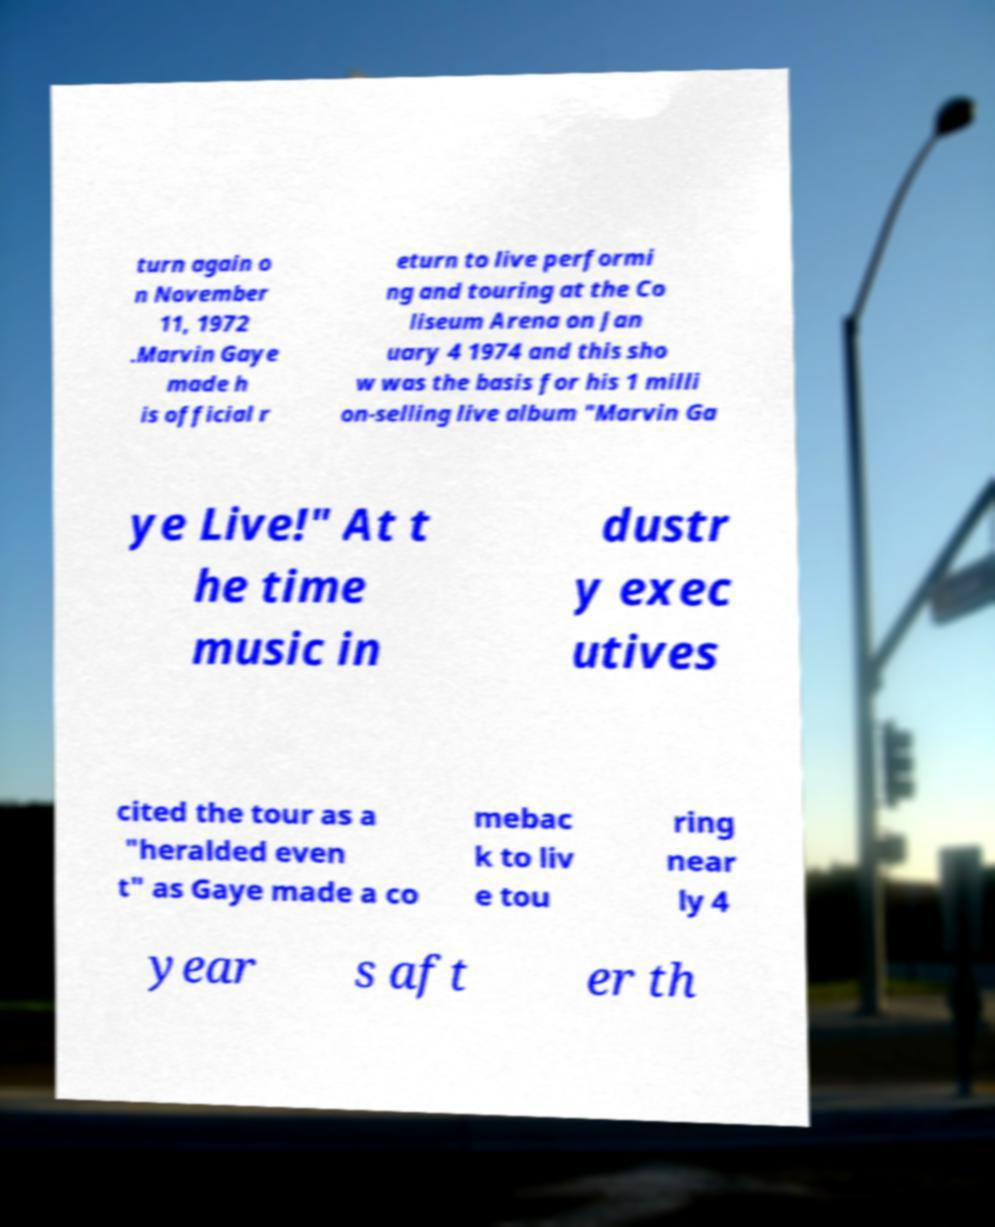Can you accurately transcribe the text from the provided image for me? turn again o n November 11, 1972 .Marvin Gaye made h is official r eturn to live performi ng and touring at the Co liseum Arena on Jan uary 4 1974 and this sho w was the basis for his 1 milli on-selling live album "Marvin Ga ye Live!" At t he time music in dustr y exec utives cited the tour as a "heralded even t" as Gaye made a co mebac k to liv e tou ring near ly 4 year s aft er th 